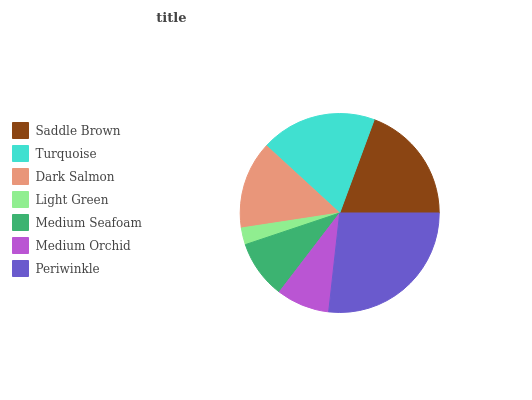Is Light Green the minimum?
Answer yes or no. Yes. Is Periwinkle the maximum?
Answer yes or no. Yes. Is Turquoise the minimum?
Answer yes or no. No. Is Turquoise the maximum?
Answer yes or no. No. Is Saddle Brown greater than Turquoise?
Answer yes or no. Yes. Is Turquoise less than Saddle Brown?
Answer yes or no. Yes. Is Turquoise greater than Saddle Brown?
Answer yes or no. No. Is Saddle Brown less than Turquoise?
Answer yes or no. No. Is Dark Salmon the high median?
Answer yes or no. Yes. Is Dark Salmon the low median?
Answer yes or no. Yes. Is Medium Seafoam the high median?
Answer yes or no. No. Is Light Green the low median?
Answer yes or no. No. 